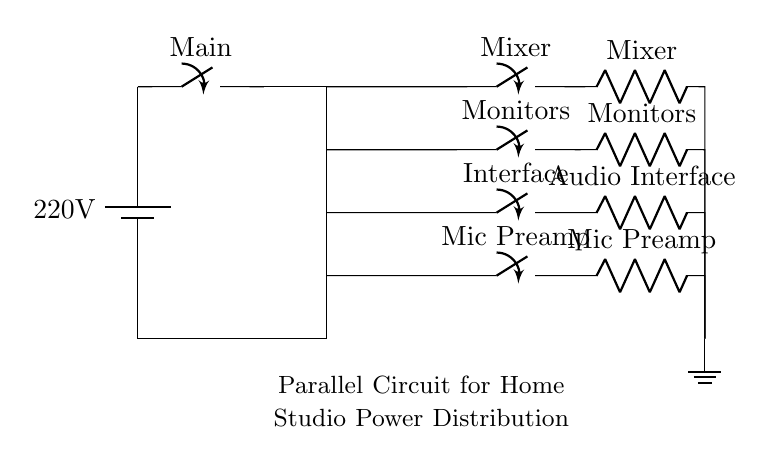What is the main voltage supply for this circuit? The main voltage supply is designated as 220V, which is shown next to the battery symbol in the diagram. This represents the input voltage for the entire circuit.
Answer: 220V What does the switch labeled "Main" control? The "Main" switch controls the overall power supply to the entire circuit, allowing you to turn off or on all connected audio equipment simultaneously.
Answer: All equipment How many branches are present in this parallel circuit? The circuit contains four branches, each connected to different audio equipment: Mixer, Monitors, Interface, and Mic Preamp. This is visible from the separate paths leading down from the main line.
Answer: Four Which component is connected directly to the Mixer? The component connected directly to the Mixer is a switch, as indicated by the pathway leading from the "Mixer" switch in the circuit. This means the Mixer can be turned on or off independently.
Answer: Mixer switch If the Mixer requires a current of 5A, what can be inferred about the current through the other branches? In a parallel circuit, the voltage across each branch is the same, but the total current is the sum of the currents through each branch. Thus, if the Mixer requires 5A, the currents through the other branches can be independent and can vary based on their respective components while maintaining 220V across them.
Answer: Independent currents What type of circuit is depicted in this diagram? The diagram clearly represents a parallel circuit, as evidenced by the multiple branches that allow for separate paths for the flow of electricity to different pieces of equipment. Each branch operates independently of the others.
Answer: Parallel circuit 